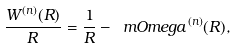Convert formula to latex. <formula><loc_0><loc_0><loc_500><loc_500>\frac { W ^ { ( n ) } ( R ) } { R } = \frac { 1 } { R } - \ m O m e g a ^ { ( n ) } ( R ) ,</formula> 